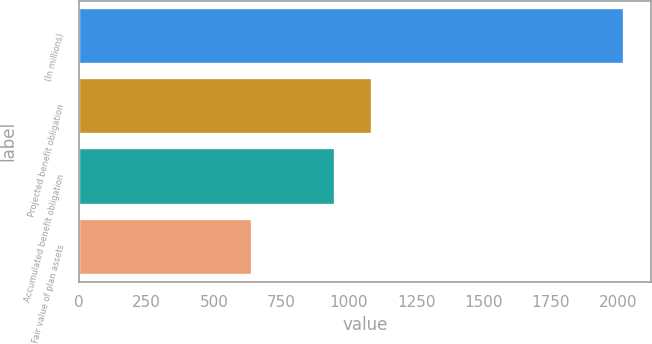Convert chart to OTSL. <chart><loc_0><loc_0><loc_500><loc_500><bar_chart><fcel>(In millions)<fcel>Projected benefit obligation<fcel>Accumulated benefit obligation<fcel>Fair value of plan assets<nl><fcel>2019<fcel>1086.7<fcel>949<fcel>642<nl></chart> 